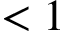Convert formula to latex. <formula><loc_0><loc_0><loc_500><loc_500>< 1</formula> 